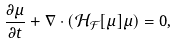<formula> <loc_0><loc_0><loc_500><loc_500>\frac { \partial \mu } { \partial t } + \nabla \cdot ( \mathcal { H } _ { \mathcal { F } } [ \mu ] \mu ) = 0 ,</formula> 